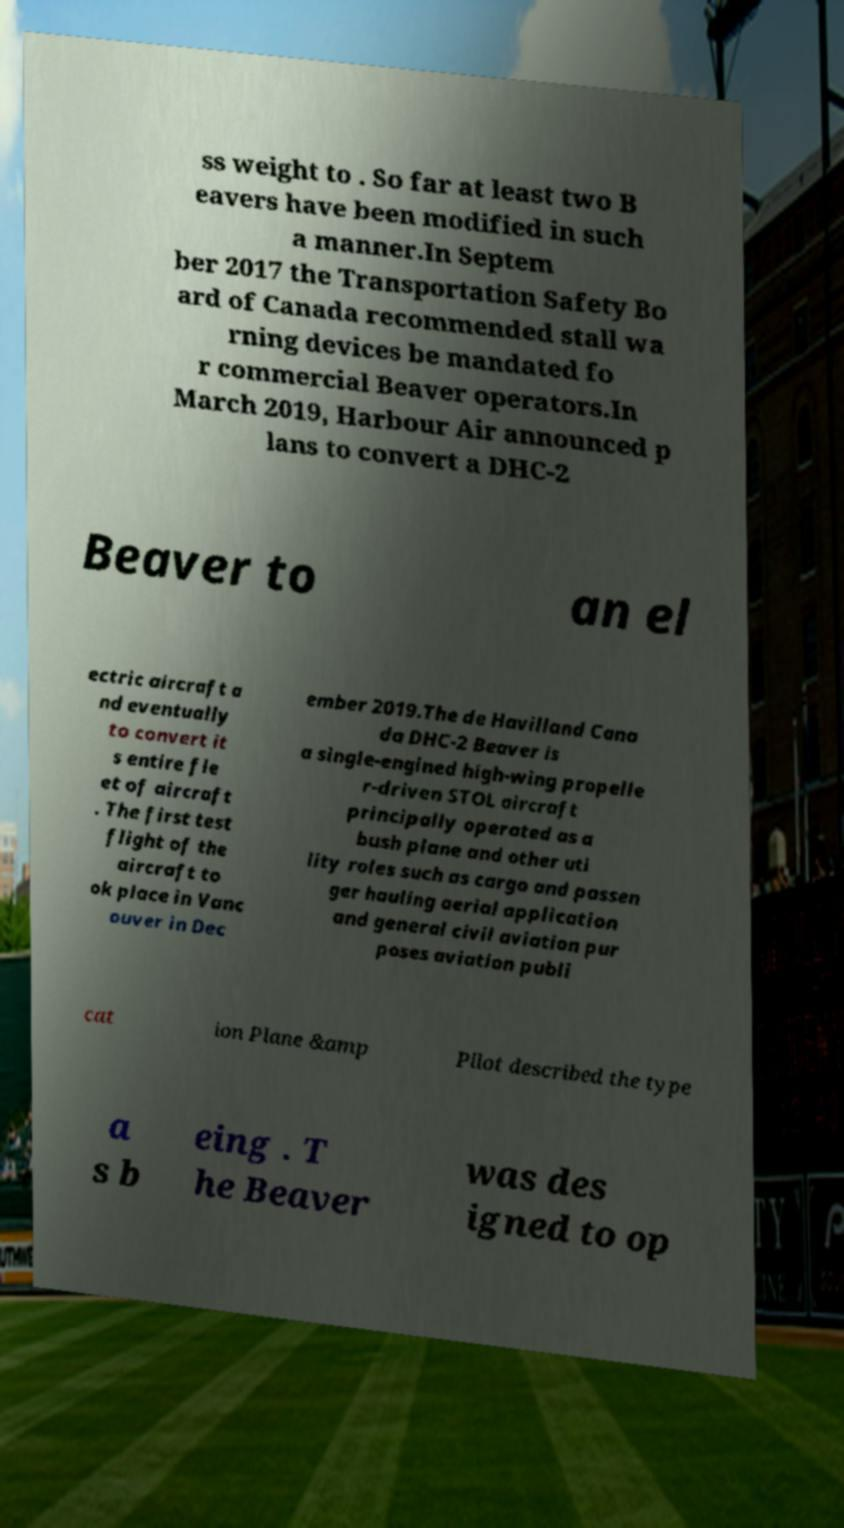Can you read and provide the text displayed in the image?This photo seems to have some interesting text. Can you extract and type it out for me? ss weight to . So far at least two B eavers have been modified in such a manner.In Septem ber 2017 the Transportation Safety Bo ard of Canada recommended stall wa rning devices be mandated fo r commercial Beaver operators.In March 2019, Harbour Air announced p lans to convert a DHC-2 Beaver to an el ectric aircraft a nd eventually to convert it s entire fle et of aircraft . The first test flight of the aircraft to ok place in Vanc ouver in Dec ember 2019.The de Havilland Cana da DHC-2 Beaver is a single-engined high-wing propelle r-driven STOL aircraft principally operated as a bush plane and other uti lity roles such as cargo and passen ger hauling aerial application and general civil aviation pur poses aviation publi cat ion Plane &amp Pilot described the type a s b eing . T he Beaver was des igned to op 